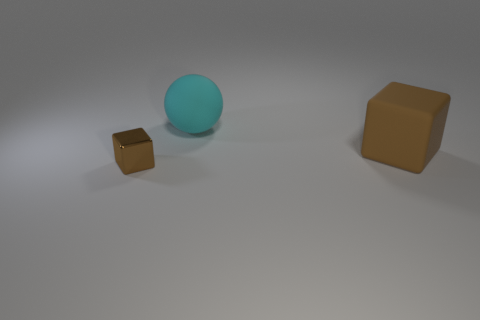What number of purple cylinders are there?
Give a very brief answer. 0. Is there any other thing that has the same size as the rubber sphere?
Your answer should be compact. Yes. Do the small thing and the large brown cube have the same material?
Make the answer very short. No. There is a brown cube in front of the big rubber block; does it have the same size as the brown block that is on the right side of the small brown shiny thing?
Keep it short and to the point. No. Is the number of large green cubes less than the number of rubber things?
Provide a succinct answer. Yes. What number of metallic things are big balls or brown blocks?
Offer a terse response. 1. Are there any small blocks on the right side of the rubber object that is in front of the big cyan matte sphere?
Give a very brief answer. No. Is the material of the brown thing behind the small brown thing the same as the small brown block?
Offer a terse response. No. How many other objects are the same color as the large matte ball?
Ensure brevity in your answer.  0. Do the shiny cube and the large rubber cube have the same color?
Your answer should be compact. Yes. 